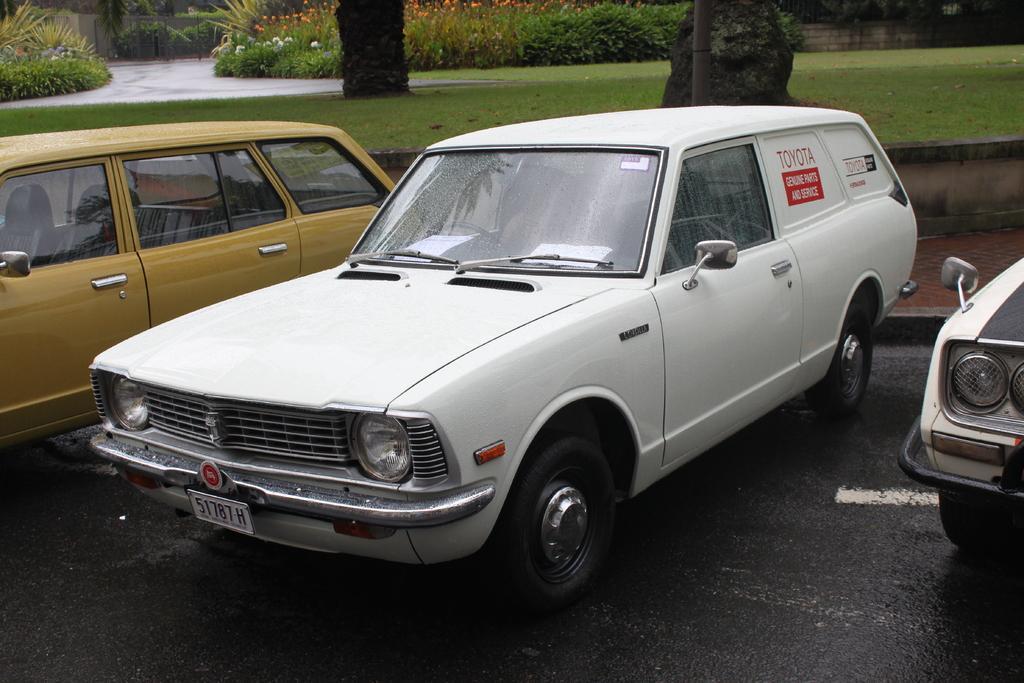Describe this image in one or two sentences. In this image I can see few vehicles. In front the vehicle is in white color, background I can see few flowers in orange and white color and the plants are in green color. 